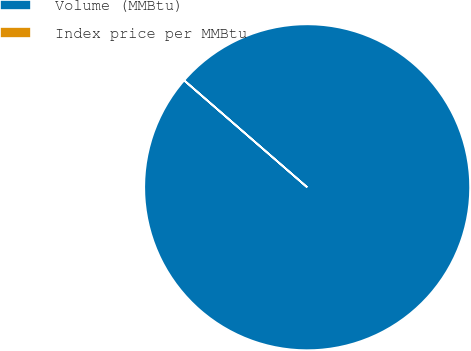Convert chart to OTSL. <chart><loc_0><loc_0><loc_500><loc_500><pie_chart><fcel>Volume (MMBtu)<fcel>Index price per MMBtu<nl><fcel>99.99%<fcel>0.01%<nl></chart> 